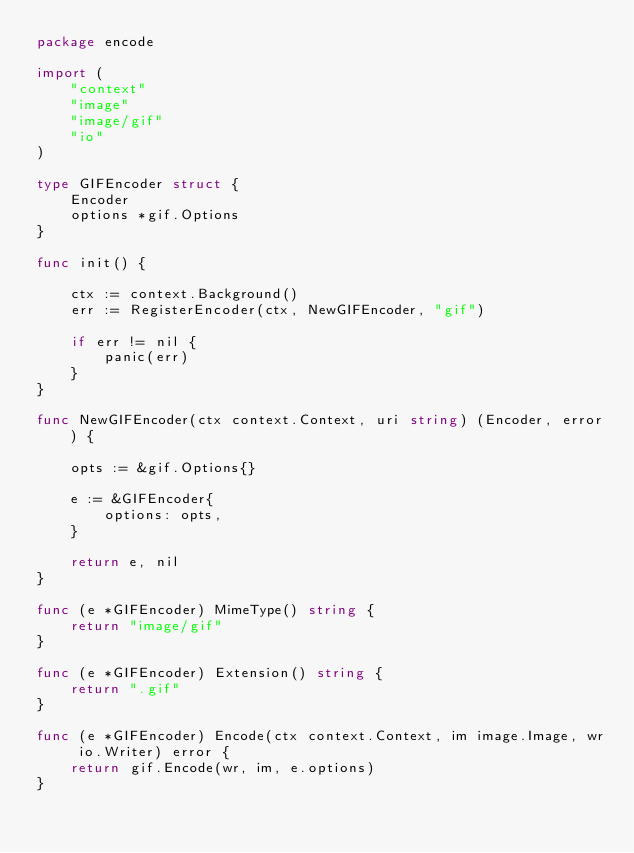<code> <loc_0><loc_0><loc_500><loc_500><_Go_>package encode

import (
	"context"
	"image"
	"image/gif"
	"io"
)

type GIFEncoder struct {
	Encoder
	options *gif.Options
}

func init() {

	ctx := context.Background()
	err := RegisterEncoder(ctx, NewGIFEncoder, "gif")

	if err != nil {
		panic(err)
	}
}

func NewGIFEncoder(ctx context.Context, uri string) (Encoder, error) {

	opts := &gif.Options{}

	e := &GIFEncoder{
		options: opts,
	}

	return e, nil
}

func (e *GIFEncoder) MimeType() string {
	return "image/gif"
}

func (e *GIFEncoder) Extension() string {
	return ".gif"
}

func (e *GIFEncoder) Encode(ctx context.Context, im image.Image, wr io.Writer) error {
	return gif.Encode(wr, im, e.options)
}
</code> 